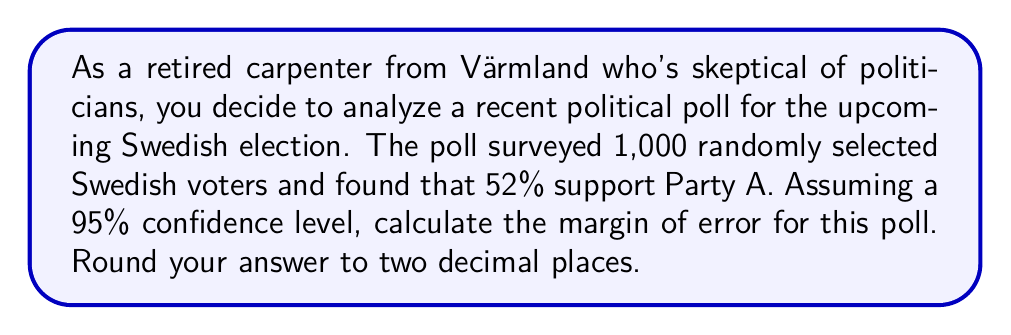What is the answer to this math problem? To calculate the margin of error for this political poll, we'll use the formula:

$$ \text{Margin of Error} = z \sqrt{\frac{p(1-p)}{n}} $$

Where:
- $z$ is the z-score for the desired confidence level (1.96 for 95% confidence)
- $p$ is the sample proportion (0.52 in this case)
- $n$ is the sample size (1,000)

Let's break it down step-by-step:

1) First, we identify our values:
   $z = 1.96$ (for 95% confidence level)
   $p = 0.52$ (52% support for Party A)
   $n = 1000$ (sample size)

2) Now, let's plug these values into our formula:

   $$ \text{Margin of Error} = 1.96 \sqrt{\frac{0.52(1-0.52)}{1000}} $$

3) Simplify inside the square root:

   $$ \text{Margin of Error} = 1.96 \sqrt{\frac{0.52(0.48)}{1000}} $$

4) Calculate inside the square root:

   $$ \text{Margin of Error} = 1.96 \sqrt{\frac{0.2496}{1000}} = 1.96 \sqrt{0.0002496} $$

5) Calculate the square root:

   $$ \text{Margin of Error} = 1.96 \times 0.0158 $$

6) Multiply:

   $$ \text{Margin of Error} = 0.03097 $$

7) Convert to a percentage and round to two decimal places:

   $$ \text{Margin of Error} = 3.10\% $$

This means that we can be 95% confident that the true proportion of Swedish voters supporting Party A is within 3.10 percentage points of the poll result (52%).
Answer: The margin of error is 3.10%. 